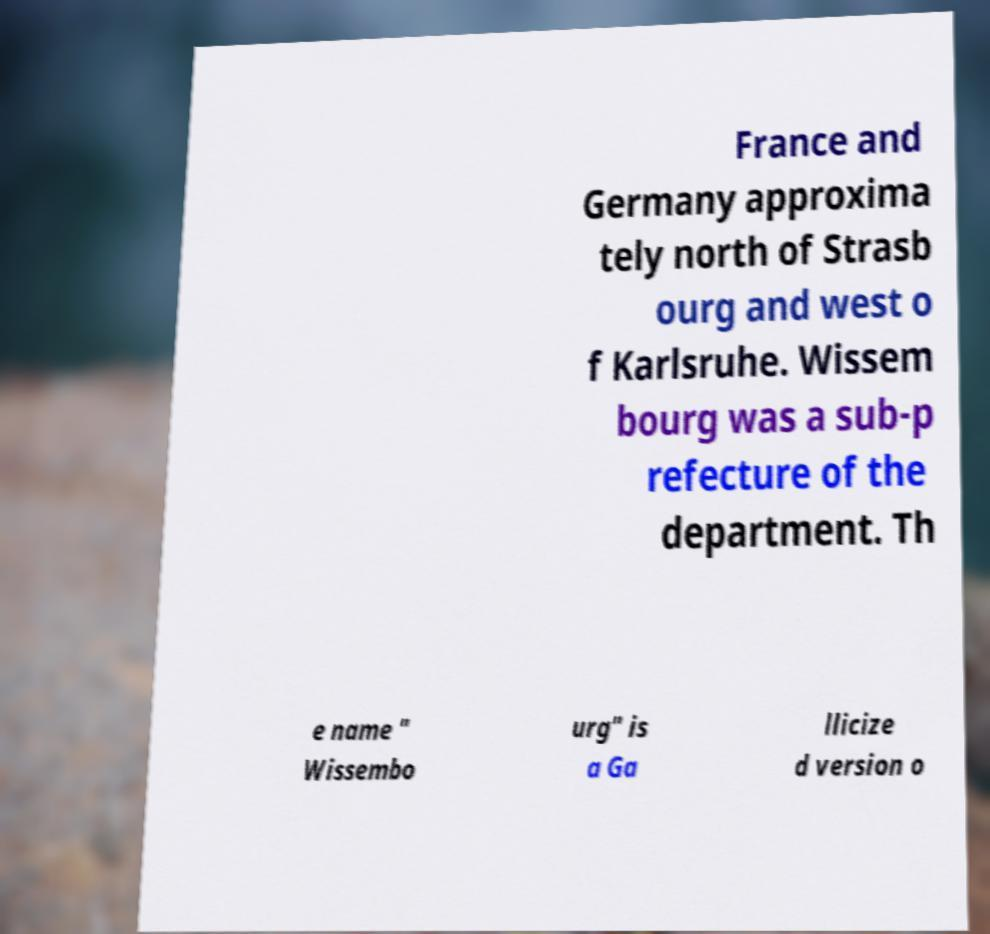What messages or text are displayed in this image? I need them in a readable, typed format. France and Germany approxima tely north of Strasb ourg and west o f Karlsruhe. Wissem bourg was a sub-p refecture of the department. Th e name " Wissembo urg" is a Ga llicize d version o 